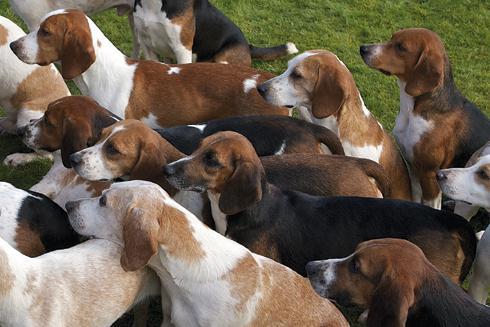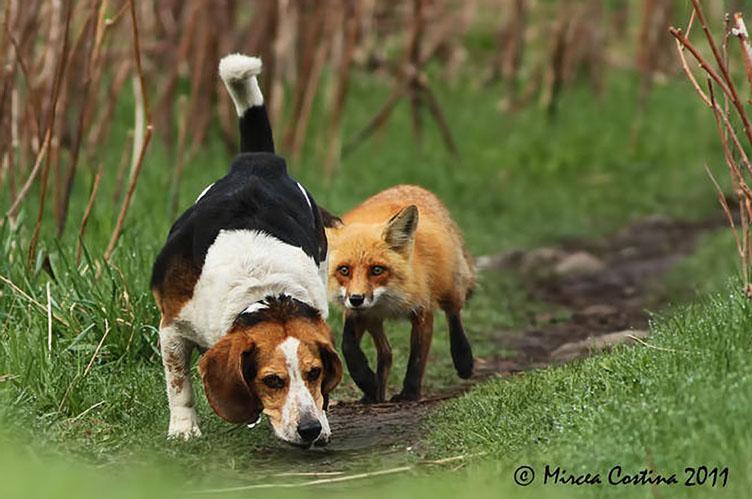The first image is the image on the left, the second image is the image on the right. Evaluate the accuracy of this statement regarding the images: "The left image contains at least three dogs.". Is it true? Answer yes or no. Yes. 